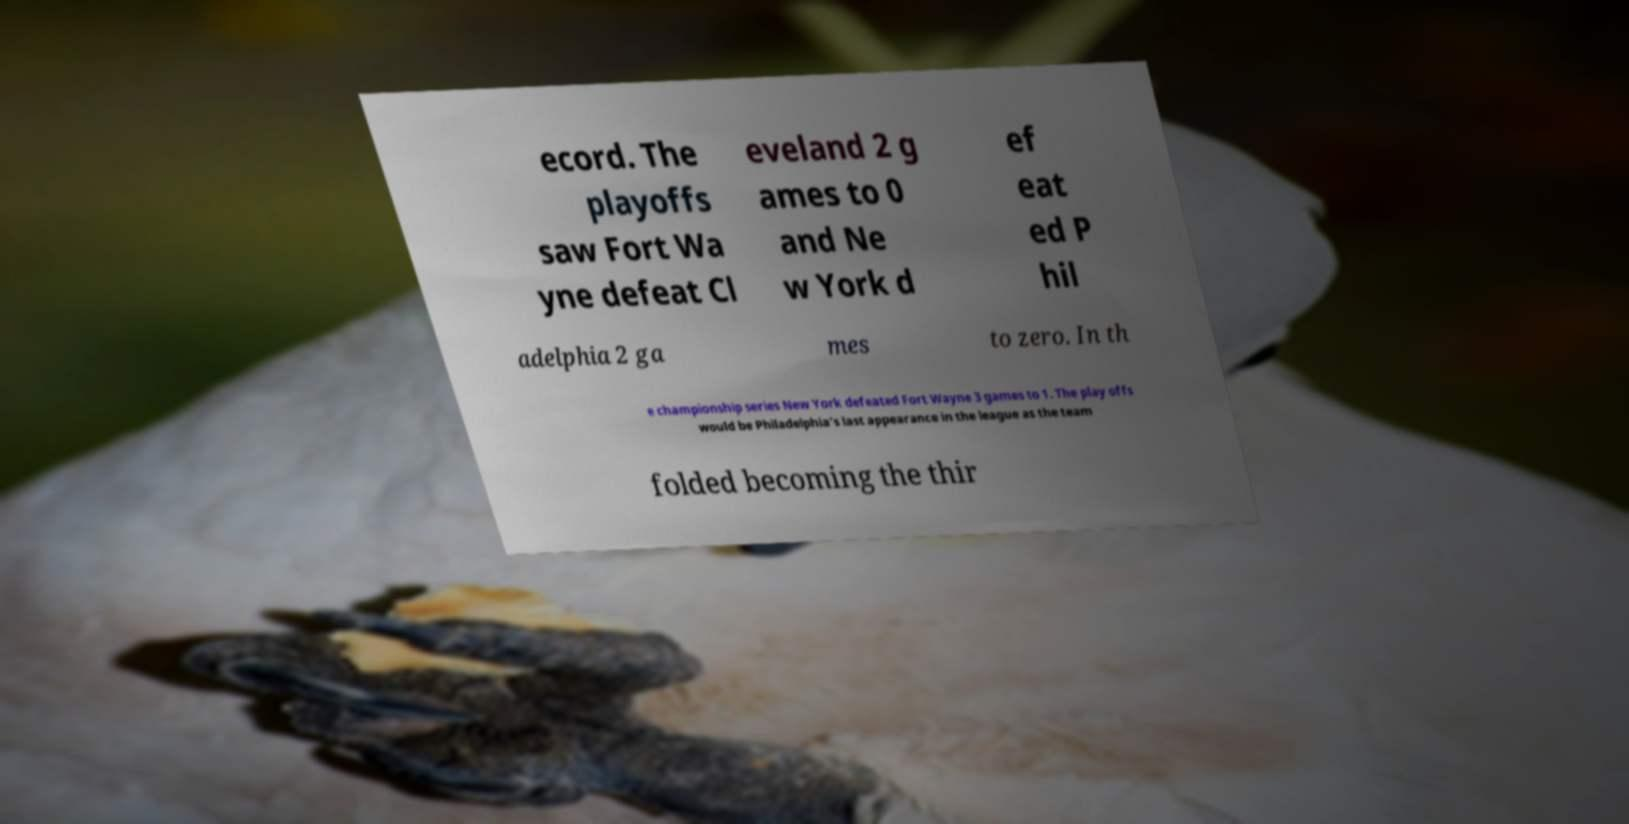Could you extract and type out the text from this image? ecord. The playoffs saw Fort Wa yne defeat Cl eveland 2 g ames to 0 and Ne w York d ef eat ed P hil adelphia 2 ga mes to zero. In th e championship series New York defeated Fort Wayne 3 games to 1. The play offs would be Philadelphia's last appearance in the league as the team folded becoming the thir 